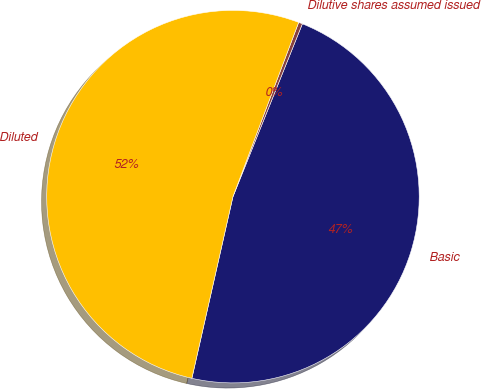<chart> <loc_0><loc_0><loc_500><loc_500><pie_chart><fcel>Basic<fcel>Dilutive shares assumed issued<fcel>Diluted<nl><fcel>47.46%<fcel>0.34%<fcel>52.2%<nl></chart> 